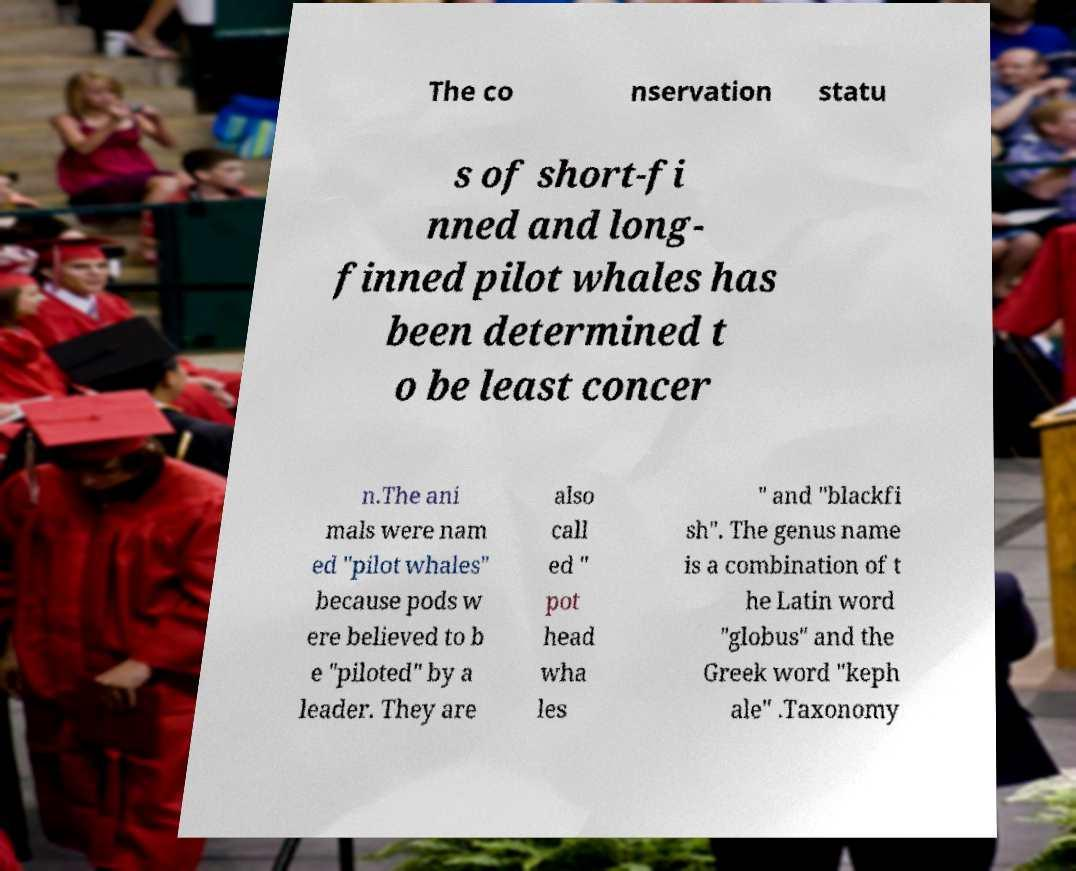Can you read and provide the text displayed in the image?This photo seems to have some interesting text. Can you extract and type it out for me? The co nservation statu s of short-fi nned and long- finned pilot whales has been determined t o be least concer n.The ani mals were nam ed "pilot whales" because pods w ere believed to b e "piloted" by a leader. They are also call ed " pot head wha les " and "blackfi sh". The genus name is a combination of t he Latin word "globus" and the Greek word "keph ale" .Taxonomy 